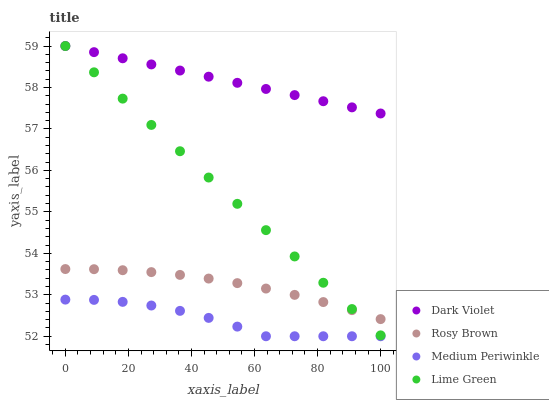Does Medium Periwinkle have the minimum area under the curve?
Answer yes or no. Yes. Does Dark Violet have the maximum area under the curve?
Answer yes or no. Yes. Does Rosy Brown have the minimum area under the curve?
Answer yes or no. No. Does Rosy Brown have the maximum area under the curve?
Answer yes or no. No. Is Lime Green the smoothest?
Answer yes or no. Yes. Is Medium Periwinkle the roughest?
Answer yes or no. Yes. Is Rosy Brown the smoothest?
Answer yes or no. No. Is Rosy Brown the roughest?
Answer yes or no. No. Does Medium Periwinkle have the lowest value?
Answer yes or no. Yes. Does Rosy Brown have the lowest value?
Answer yes or no. No. Does Dark Violet have the highest value?
Answer yes or no. Yes. Does Rosy Brown have the highest value?
Answer yes or no. No. Is Medium Periwinkle less than Dark Violet?
Answer yes or no. Yes. Is Lime Green greater than Medium Periwinkle?
Answer yes or no. Yes. Does Lime Green intersect Dark Violet?
Answer yes or no. Yes. Is Lime Green less than Dark Violet?
Answer yes or no. No. Is Lime Green greater than Dark Violet?
Answer yes or no. No. Does Medium Periwinkle intersect Dark Violet?
Answer yes or no. No. 